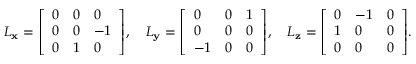Convert formula to latex. <formula><loc_0><loc_0><loc_500><loc_500>L _ { x } = { \left [ \begin{array} { l l l } { 0 } & { 0 } & { 0 } \\ { 0 } & { 0 } & { - 1 } \\ { 0 } & { 1 } & { 0 } \end{array} \right ] } , \quad L _ { y } = { \left [ \begin{array} { l l l } { 0 } & { 0 } & { 1 } \\ { 0 } & { 0 } & { 0 } \\ { - 1 } & { 0 } & { 0 } \end{array} \right ] } , \quad L _ { z } = { \left [ \begin{array} { l l l } { 0 } & { - 1 } & { 0 } \\ { 1 } & { 0 } & { 0 } \\ { 0 } & { 0 } & { 0 } \end{array} \right ] } .</formula> 